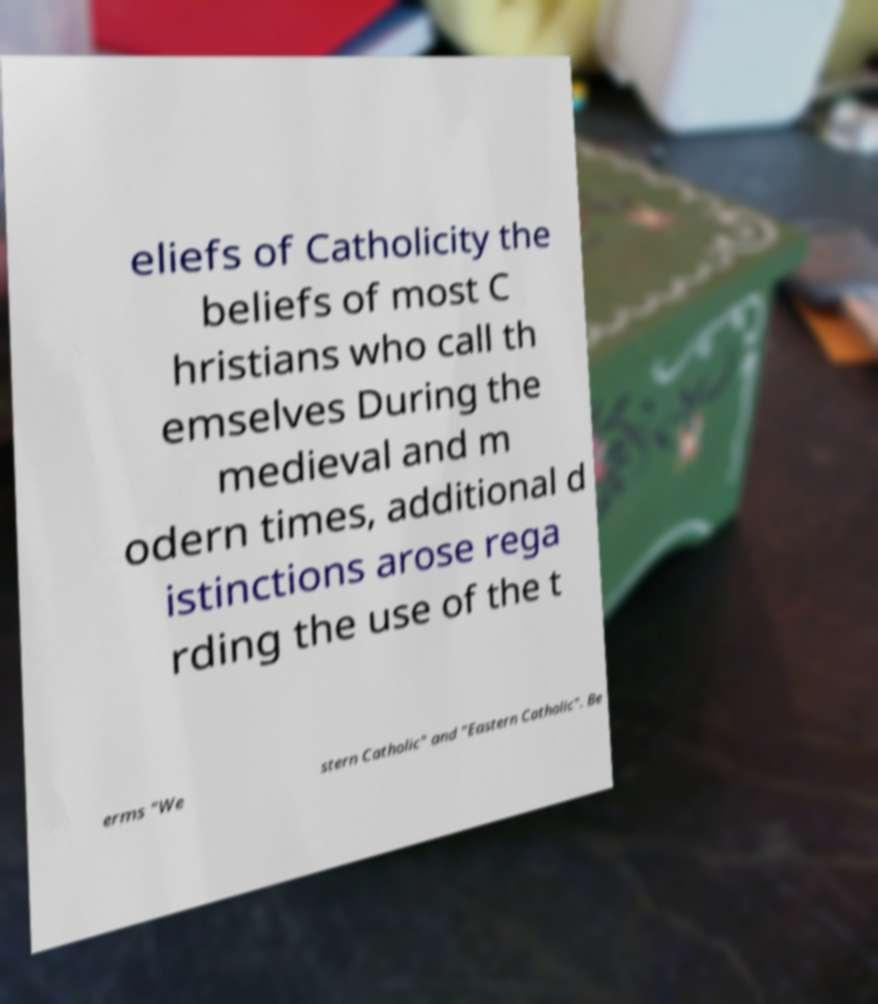There's text embedded in this image that I need extracted. Can you transcribe it verbatim? eliefs of Catholicity the beliefs of most C hristians who call th emselves During the medieval and m odern times, additional d istinctions arose rega rding the use of the t erms "We stern Catholic" and "Eastern Catholic". Be 